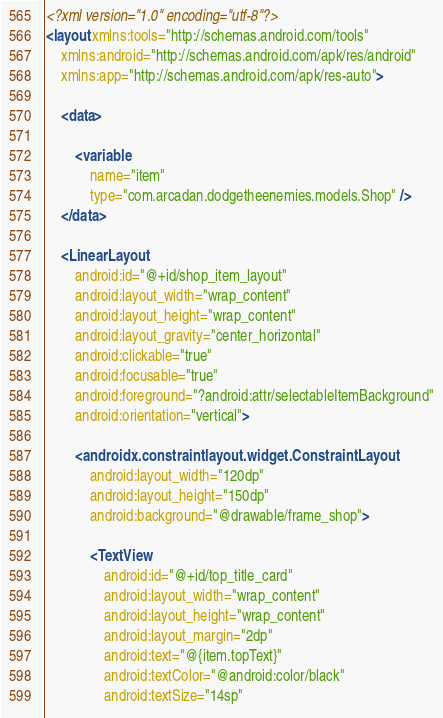Convert code to text. <code><loc_0><loc_0><loc_500><loc_500><_XML_><?xml version="1.0" encoding="utf-8"?>
<layout xmlns:tools="http://schemas.android.com/tools"
    xmlns:android="http://schemas.android.com/apk/res/android"
    xmlns:app="http://schemas.android.com/apk/res-auto">

    <data>

        <variable
            name="item"
            type="com.arcadan.dodgetheenemies.models.Shop" />
    </data>

    <LinearLayout
        android:id="@+id/shop_item_layout"
        android:layout_width="wrap_content"
        android:layout_height="wrap_content"
        android:layout_gravity="center_horizontal"
        android:clickable="true"
        android:focusable="true"
        android:foreground="?android:attr/selectableItemBackground"
        android:orientation="vertical">

        <androidx.constraintlayout.widget.ConstraintLayout
            android:layout_width="120dp"
            android:layout_height="150dp"
            android:background="@drawable/frame_shop">

            <TextView
                android:id="@+id/top_title_card"
                android:layout_width="wrap_content"
                android:layout_height="wrap_content"
                android:layout_margin="2dp"
                android:text="@{item.topText}"
                android:textColor="@android:color/black"
                android:textSize="14sp"</code> 